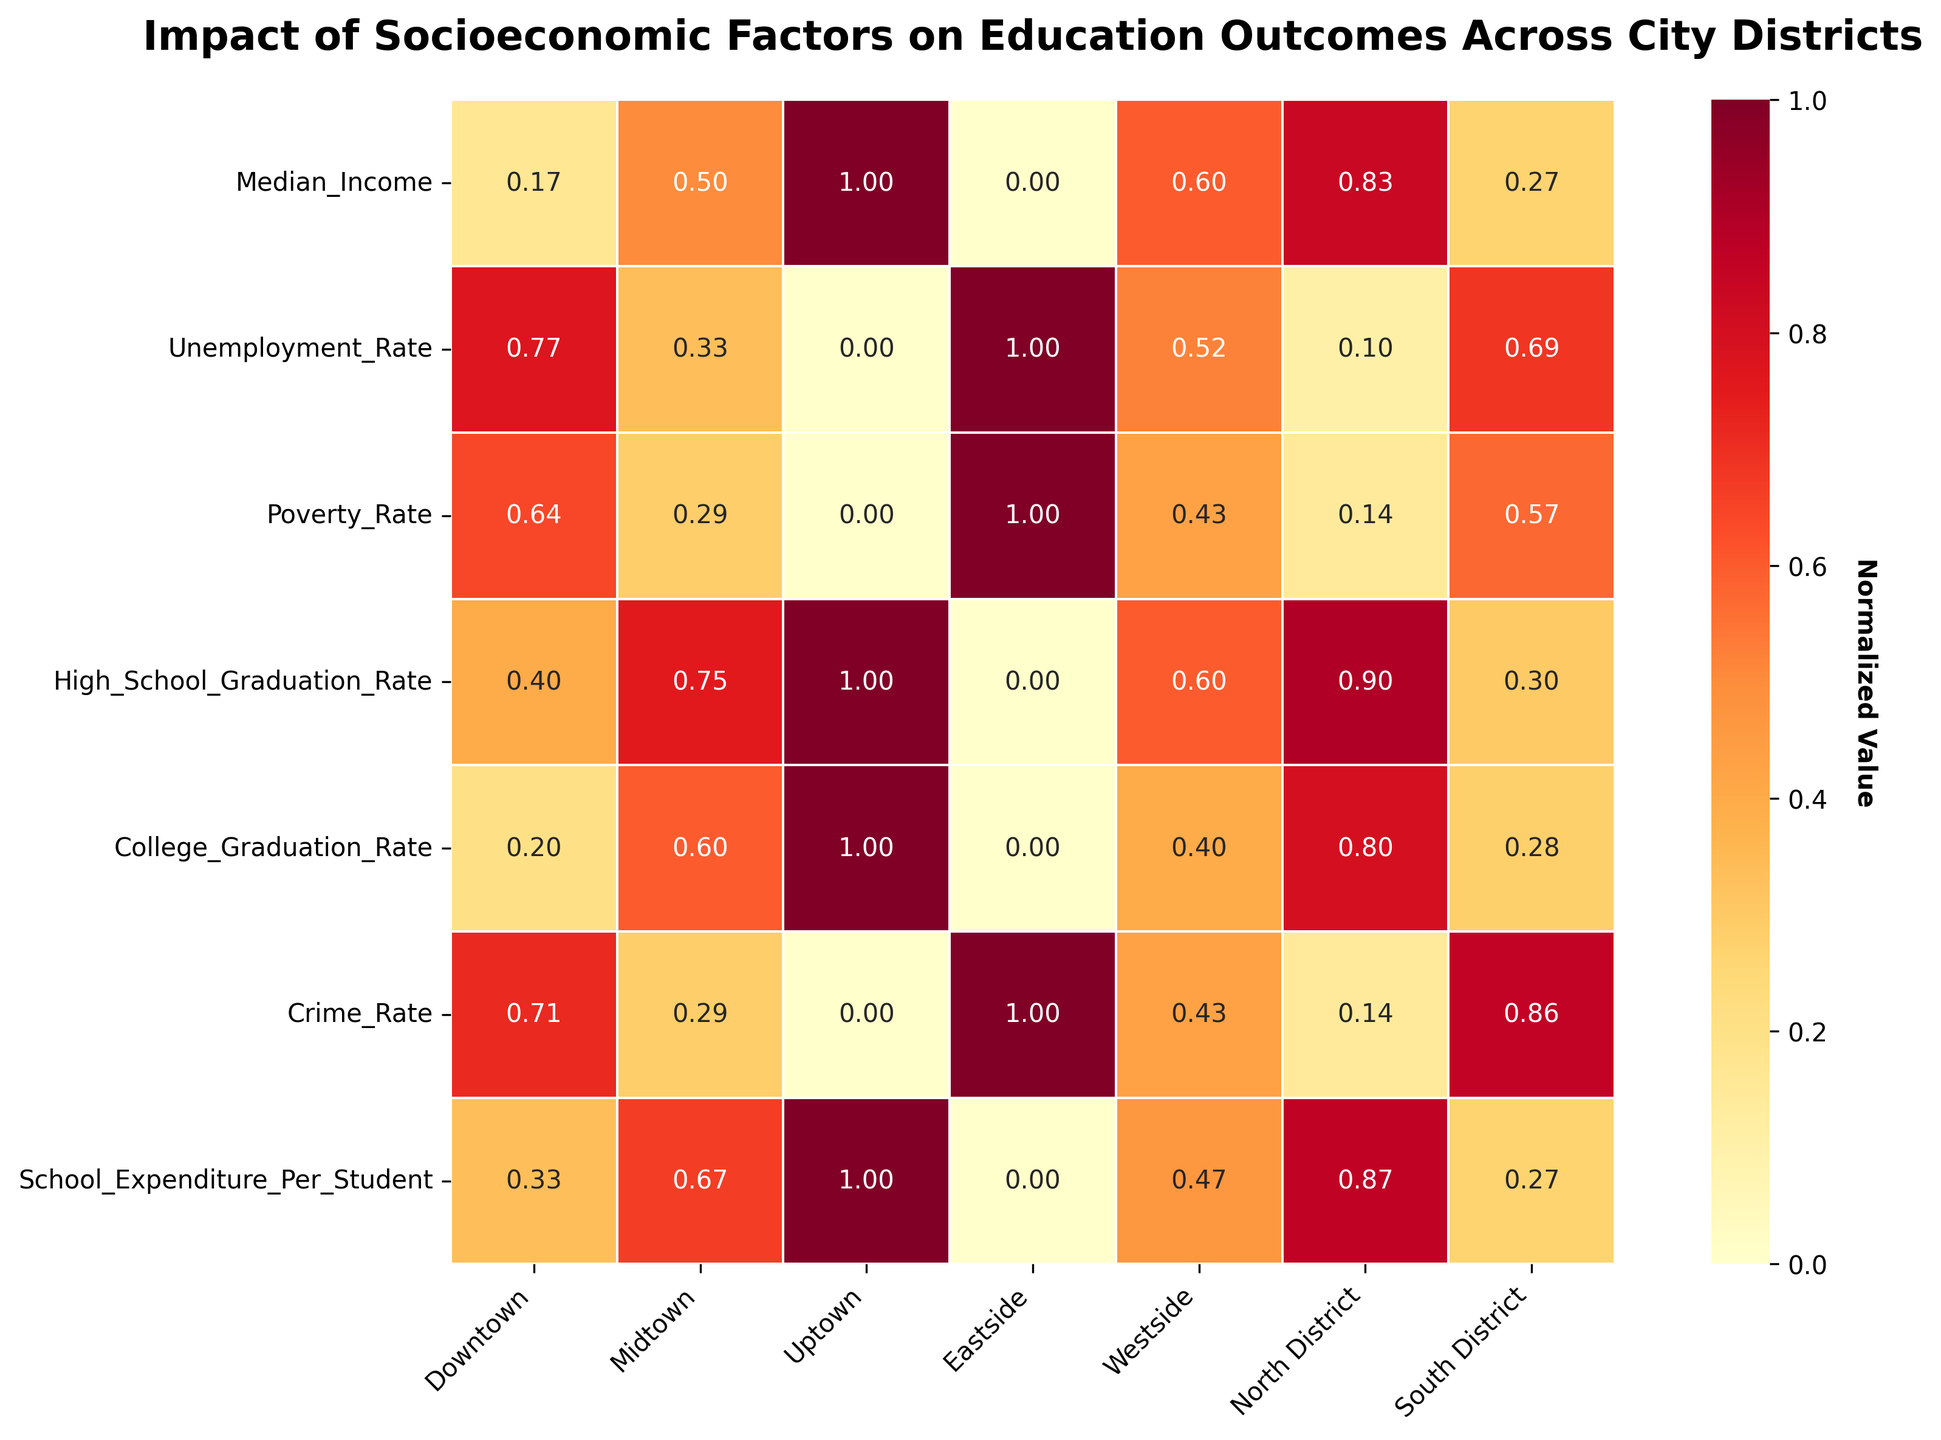What's the title of the heatmap? The title is located at the top of the figure and summarizes the main theme or focus of the visualization.
Answer: Impact of Socioeconomic Factors on Education Outcomes Across City Districts Which district has the lowest normalized College Graduation Rate? Check the College Graduation Rate row and find the cell with the smallest value.
Answer: Eastside Compare the normalized Median Income between Uptown and Eastside. Which is higher? Locate the Median Income row and compare the values for Uptown and Eastside. Uptown has a higher normalized value.
Answer: Uptown What is the normalization range for the High School Graduation Rate across all districts? Normalization ranges from 0 to 1. Identify the smallest and largest normalized values in the High School Graduation Rate row.
Answer: 0 to 1 Which district has the highest normalized value for School Expenditure Per Student? Look at the School Expenditure Per Student row and identify the cell with the highest value.
Answer: Uptown For the South District, which socioeconomic factor has the highest normalized value? Check the South District column and find the row with the highest value.
Answer: Crime Rate What is the color range used in the heatmap? Observe the color scale bar on the side. The color ranges from light to dark, with light colors representing lower values and dark colors representing higher values.
Answer: Light yellow to dark red How does the normalized Crime Rate in Downtown compare to North District? Compare the values in the Crime Rate row for Downtown and North District. Downtown has a higher normalized value.
Answer: Downtown Which district shows the biggest disparity between High School Graduation Rate and College Graduation Rate? For each district, calculate the difference between the normalized values of High School Graduation Rate and College Graduation Rate, and find the district with the largest difference.
Answer: Eastside If Poverty Rate is inversely related to Median Income, which district's data supports this trend most strongly? Compare normalized values of Poverty Rate and Median Income for each district. The biggest contrast will support this trend.
Answer: Eastside 